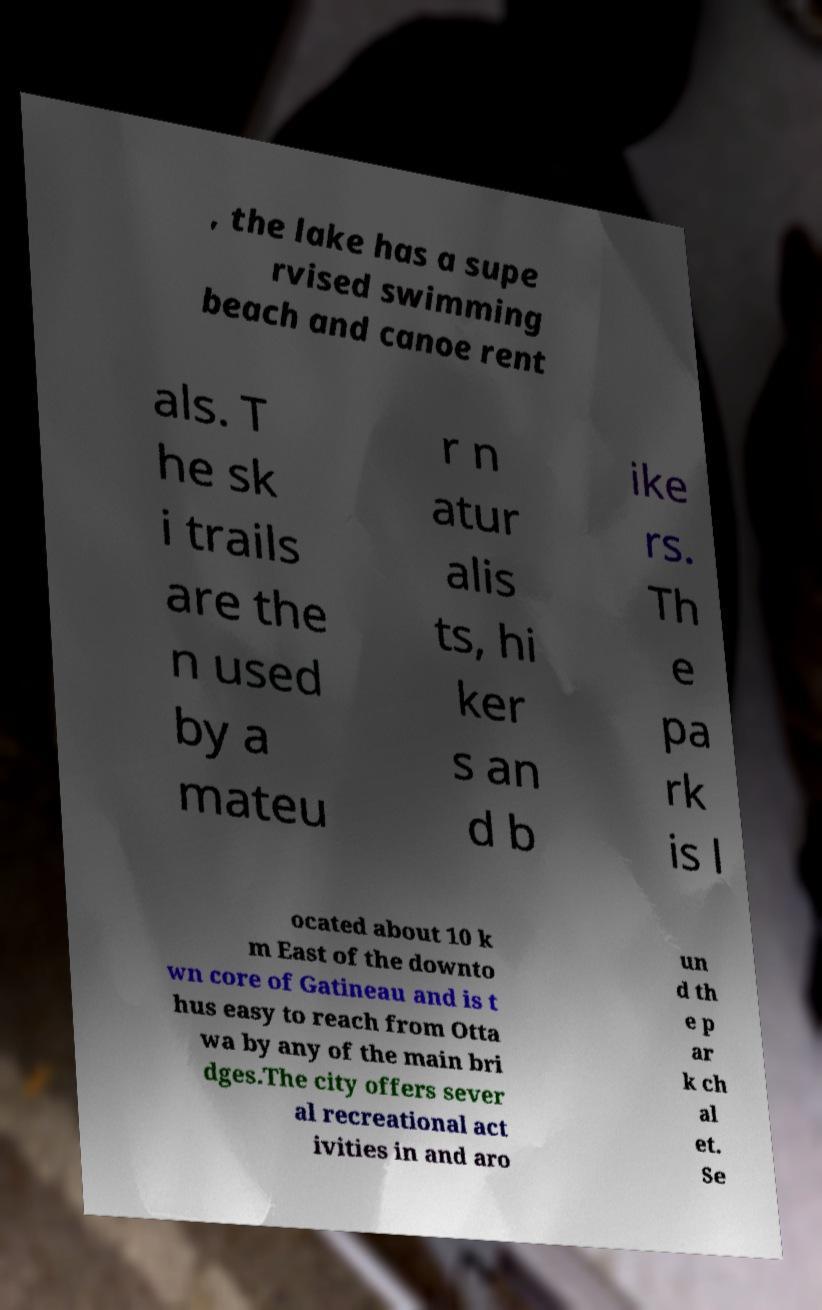Please read and relay the text visible in this image. What does it say? , the lake has a supe rvised swimming beach and canoe rent als. T he sk i trails are the n used by a mateu r n atur alis ts, hi ker s an d b ike rs. Th e pa rk is l ocated about 10 k m East of the downto wn core of Gatineau and is t hus easy to reach from Otta wa by any of the main bri dges.The city offers sever al recreational act ivities in and aro un d th e p ar k ch al et. Se 